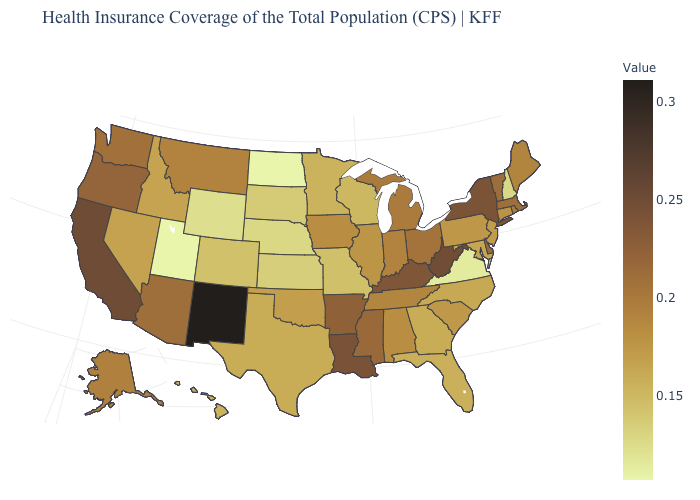Which states hav the highest value in the West?
Write a very short answer. New Mexico. Among the states that border Louisiana , which have the highest value?
Keep it brief. Arkansas. Among the states that border Pennsylvania , does Maryland have the highest value?
Concise answer only. No. Is the legend a continuous bar?
Concise answer only. Yes. 